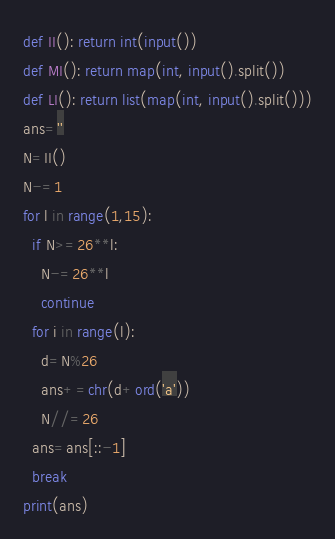Convert code to text. <code><loc_0><loc_0><loc_500><loc_500><_Python_>def II(): return int(input())
def MI(): return map(int, input().split())
def LI(): return list(map(int, input().split()))
ans=''
N=II()
N-=1
for l in range(1,15):
  if N>=26**l:
    N-=26**l
    continue
  for i in range(l):
    d=N%26
    ans+=chr(d+ord('a'))
    N//=26
  ans=ans[::-1]
  break
print(ans)
</code> 